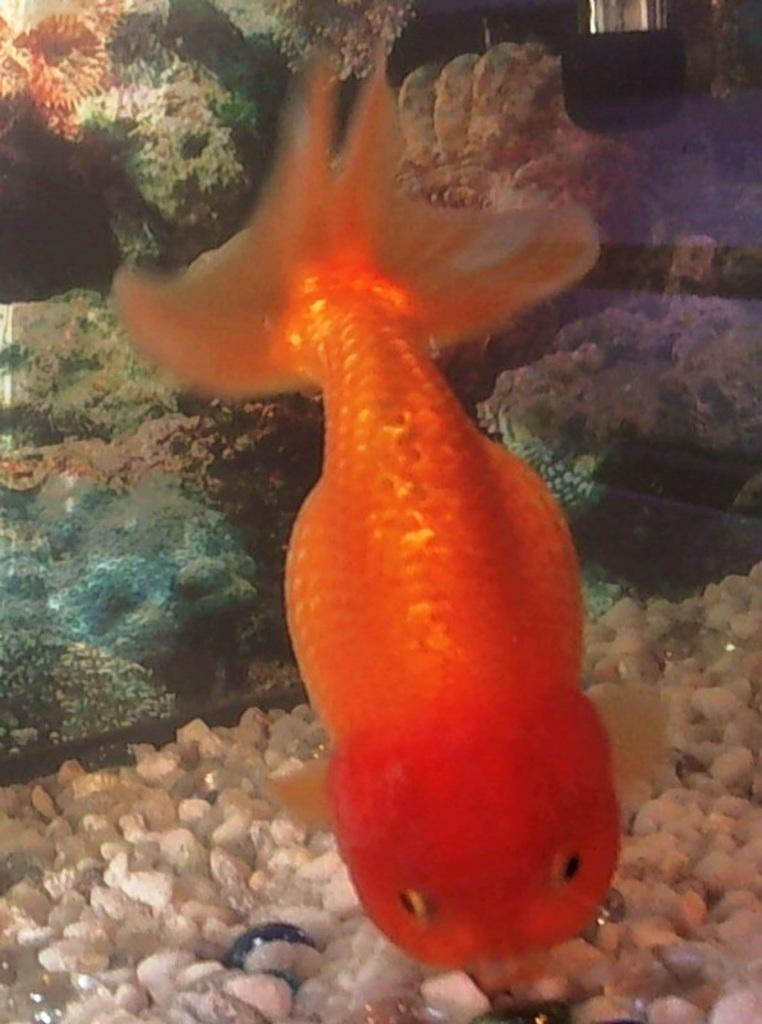What type of animal is in the image? There is a fish in the image. What other objects can be seen in the image? There are stones and rocks in the image. Where are the rocks and stones located? The rocks and stones are in the water. What is visible in the background of the image? There is an object visible in the background of the image. What does the fish's dad say about the thumb in the image? There is no dad or thumb present in the image, as it only features a fish, stones, rocks, and an object in the background. 